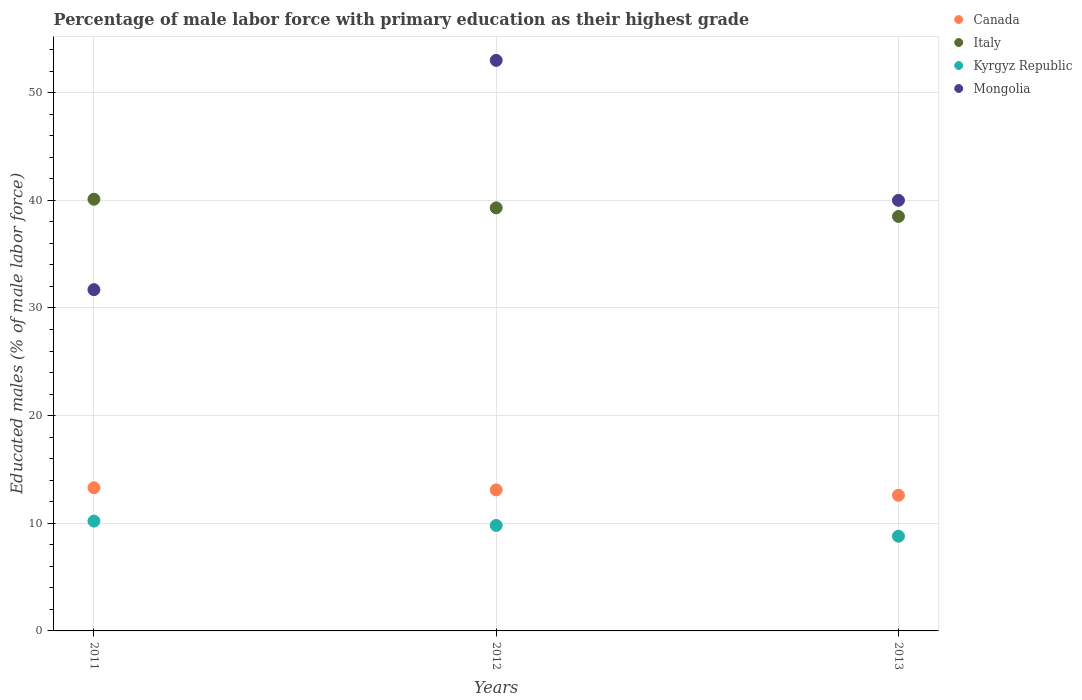How many different coloured dotlines are there?
Your answer should be compact. 4. Across all years, what is the maximum percentage of male labor force with primary education in Italy?
Offer a terse response. 40.1. Across all years, what is the minimum percentage of male labor force with primary education in Canada?
Make the answer very short. 12.6. What is the total percentage of male labor force with primary education in Kyrgyz Republic in the graph?
Offer a terse response. 28.8. What is the difference between the percentage of male labor force with primary education in Italy in 2011 and that in 2012?
Your answer should be very brief. 0.8. What is the difference between the percentage of male labor force with primary education in Kyrgyz Republic in 2011 and the percentage of male labor force with primary education in Italy in 2013?
Keep it short and to the point. -28.3. What is the average percentage of male labor force with primary education in Kyrgyz Republic per year?
Provide a short and direct response. 9.6. In the year 2012, what is the difference between the percentage of male labor force with primary education in Kyrgyz Republic and percentage of male labor force with primary education in Canada?
Ensure brevity in your answer.  -3.3. In how many years, is the percentage of male labor force with primary education in Italy greater than 12 %?
Keep it short and to the point. 3. What is the ratio of the percentage of male labor force with primary education in Italy in 2012 to that in 2013?
Keep it short and to the point. 1.02. What is the difference between the highest and the second highest percentage of male labor force with primary education in Canada?
Provide a short and direct response. 0.2. What is the difference between the highest and the lowest percentage of male labor force with primary education in Kyrgyz Republic?
Your answer should be very brief. 1.4. In how many years, is the percentage of male labor force with primary education in Canada greater than the average percentage of male labor force with primary education in Canada taken over all years?
Your answer should be very brief. 2. Is it the case that in every year, the sum of the percentage of male labor force with primary education in Mongolia and percentage of male labor force with primary education in Kyrgyz Republic  is greater than the sum of percentage of male labor force with primary education in Canada and percentage of male labor force with primary education in Italy?
Make the answer very short. Yes. Is it the case that in every year, the sum of the percentage of male labor force with primary education in Canada and percentage of male labor force with primary education in Mongolia  is greater than the percentage of male labor force with primary education in Kyrgyz Republic?
Provide a succinct answer. Yes. How many dotlines are there?
Provide a short and direct response. 4. What is the difference between two consecutive major ticks on the Y-axis?
Your answer should be compact. 10. Does the graph contain grids?
Offer a very short reply. Yes. Where does the legend appear in the graph?
Provide a succinct answer. Top right. How many legend labels are there?
Offer a very short reply. 4. How are the legend labels stacked?
Provide a succinct answer. Vertical. What is the title of the graph?
Provide a succinct answer. Percentage of male labor force with primary education as their highest grade. Does "Cambodia" appear as one of the legend labels in the graph?
Provide a succinct answer. No. What is the label or title of the X-axis?
Make the answer very short. Years. What is the label or title of the Y-axis?
Give a very brief answer. Educated males (% of male labor force). What is the Educated males (% of male labor force) in Canada in 2011?
Give a very brief answer. 13.3. What is the Educated males (% of male labor force) of Italy in 2011?
Make the answer very short. 40.1. What is the Educated males (% of male labor force) in Kyrgyz Republic in 2011?
Provide a succinct answer. 10.2. What is the Educated males (% of male labor force) of Mongolia in 2011?
Your answer should be very brief. 31.7. What is the Educated males (% of male labor force) in Canada in 2012?
Offer a very short reply. 13.1. What is the Educated males (% of male labor force) in Italy in 2012?
Keep it short and to the point. 39.3. What is the Educated males (% of male labor force) in Kyrgyz Republic in 2012?
Ensure brevity in your answer.  9.8. What is the Educated males (% of male labor force) in Mongolia in 2012?
Your answer should be very brief. 53. What is the Educated males (% of male labor force) of Canada in 2013?
Make the answer very short. 12.6. What is the Educated males (% of male labor force) in Italy in 2013?
Your answer should be very brief. 38.5. What is the Educated males (% of male labor force) in Kyrgyz Republic in 2013?
Your answer should be compact. 8.8. What is the Educated males (% of male labor force) in Mongolia in 2013?
Your response must be concise. 40. Across all years, what is the maximum Educated males (% of male labor force) of Canada?
Your answer should be compact. 13.3. Across all years, what is the maximum Educated males (% of male labor force) in Italy?
Make the answer very short. 40.1. Across all years, what is the maximum Educated males (% of male labor force) of Kyrgyz Republic?
Provide a succinct answer. 10.2. Across all years, what is the maximum Educated males (% of male labor force) of Mongolia?
Provide a short and direct response. 53. Across all years, what is the minimum Educated males (% of male labor force) of Canada?
Ensure brevity in your answer.  12.6. Across all years, what is the minimum Educated males (% of male labor force) in Italy?
Ensure brevity in your answer.  38.5. Across all years, what is the minimum Educated males (% of male labor force) in Kyrgyz Republic?
Provide a short and direct response. 8.8. Across all years, what is the minimum Educated males (% of male labor force) in Mongolia?
Ensure brevity in your answer.  31.7. What is the total Educated males (% of male labor force) of Canada in the graph?
Offer a terse response. 39. What is the total Educated males (% of male labor force) in Italy in the graph?
Offer a very short reply. 117.9. What is the total Educated males (% of male labor force) in Kyrgyz Republic in the graph?
Offer a terse response. 28.8. What is the total Educated males (% of male labor force) in Mongolia in the graph?
Keep it short and to the point. 124.7. What is the difference between the Educated males (% of male labor force) of Canada in 2011 and that in 2012?
Your answer should be very brief. 0.2. What is the difference between the Educated males (% of male labor force) of Mongolia in 2011 and that in 2012?
Offer a very short reply. -21.3. What is the difference between the Educated males (% of male labor force) in Canada in 2011 and that in 2013?
Offer a terse response. 0.7. What is the difference between the Educated males (% of male labor force) of Italy in 2011 and that in 2013?
Provide a short and direct response. 1.6. What is the difference between the Educated males (% of male labor force) in Mongolia in 2012 and that in 2013?
Provide a succinct answer. 13. What is the difference between the Educated males (% of male labor force) of Canada in 2011 and the Educated males (% of male labor force) of Kyrgyz Republic in 2012?
Provide a short and direct response. 3.5. What is the difference between the Educated males (% of male labor force) of Canada in 2011 and the Educated males (% of male labor force) of Mongolia in 2012?
Provide a succinct answer. -39.7. What is the difference between the Educated males (% of male labor force) of Italy in 2011 and the Educated males (% of male labor force) of Kyrgyz Republic in 2012?
Provide a short and direct response. 30.3. What is the difference between the Educated males (% of male labor force) of Italy in 2011 and the Educated males (% of male labor force) of Mongolia in 2012?
Provide a succinct answer. -12.9. What is the difference between the Educated males (% of male labor force) in Kyrgyz Republic in 2011 and the Educated males (% of male labor force) in Mongolia in 2012?
Keep it short and to the point. -42.8. What is the difference between the Educated males (% of male labor force) of Canada in 2011 and the Educated males (% of male labor force) of Italy in 2013?
Your response must be concise. -25.2. What is the difference between the Educated males (% of male labor force) in Canada in 2011 and the Educated males (% of male labor force) in Kyrgyz Republic in 2013?
Your answer should be compact. 4.5. What is the difference between the Educated males (% of male labor force) of Canada in 2011 and the Educated males (% of male labor force) of Mongolia in 2013?
Offer a very short reply. -26.7. What is the difference between the Educated males (% of male labor force) in Italy in 2011 and the Educated males (% of male labor force) in Kyrgyz Republic in 2013?
Keep it short and to the point. 31.3. What is the difference between the Educated males (% of male labor force) in Italy in 2011 and the Educated males (% of male labor force) in Mongolia in 2013?
Provide a succinct answer. 0.1. What is the difference between the Educated males (% of male labor force) in Kyrgyz Republic in 2011 and the Educated males (% of male labor force) in Mongolia in 2013?
Make the answer very short. -29.8. What is the difference between the Educated males (% of male labor force) in Canada in 2012 and the Educated males (% of male labor force) in Italy in 2013?
Provide a short and direct response. -25.4. What is the difference between the Educated males (% of male labor force) of Canada in 2012 and the Educated males (% of male labor force) of Kyrgyz Republic in 2013?
Provide a succinct answer. 4.3. What is the difference between the Educated males (% of male labor force) of Canada in 2012 and the Educated males (% of male labor force) of Mongolia in 2013?
Offer a very short reply. -26.9. What is the difference between the Educated males (% of male labor force) in Italy in 2012 and the Educated males (% of male labor force) in Kyrgyz Republic in 2013?
Your answer should be very brief. 30.5. What is the difference between the Educated males (% of male labor force) of Kyrgyz Republic in 2012 and the Educated males (% of male labor force) of Mongolia in 2013?
Provide a succinct answer. -30.2. What is the average Educated males (% of male labor force) in Canada per year?
Provide a succinct answer. 13. What is the average Educated males (% of male labor force) of Italy per year?
Ensure brevity in your answer.  39.3. What is the average Educated males (% of male labor force) in Kyrgyz Republic per year?
Ensure brevity in your answer.  9.6. What is the average Educated males (% of male labor force) in Mongolia per year?
Your response must be concise. 41.57. In the year 2011, what is the difference between the Educated males (% of male labor force) of Canada and Educated males (% of male labor force) of Italy?
Your answer should be compact. -26.8. In the year 2011, what is the difference between the Educated males (% of male labor force) of Canada and Educated males (% of male labor force) of Kyrgyz Republic?
Offer a terse response. 3.1. In the year 2011, what is the difference between the Educated males (% of male labor force) in Canada and Educated males (% of male labor force) in Mongolia?
Provide a succinct answer. -18.4. In the year 2011, what is the difference between the Educated males (% of male labor force) of Italy and Educated males (% of male labor force) of Kyrgyz Republic?
Keep it short and to the point. 29.9. In the year 2011, what is the difference between the Educated males (% of male labor force) of Kyrgyz Republic and Educated males (% of male labor force) of Mongolia?
Provide a succinct answer. -21.5. In the year 2012, what is the difference between the Educated males (% of male labor force) of Canada and Educated males (% of male labor force) of Italy?
Offer a terse response. -26.2. In the year 2012, what is the difference between the Educated males (% of male labor force) in Canada and Educated males (% of male labor force) in Mongolia?
Your answer should be very brief. -39.9. In the year 2012, what is the difference between the Educated males (% of male labor force) of Italy and Educated males (% of male labor force) of Kyrgyz Republic?
Keep it short and to the point. 29.5. In the year 2012, what is the difference between the Educated males (% of male labor force) in Italy and Educated males (% of male labor force) in Mongolia?
Provide a succinct answer. -13.7. In the year 2012, what is the difference between the Educated males (% of male labor force) in Kyrgyz Republic and Educated males (% of male labor force) in Mongolia?
Keep it short and to the point. -43.2. In the year 2013, what is the difference between the Educated males (% of male labor force) of Canada and Educated males (% of male labor force) of Italy?
Keep it short and to the point. -25.9. In the year 2013, what is the difference between the Educated males (% of male labor force) of Canada and Educated males (% of male labor force) of Mongolia?
Provide a short and direct response. -27.4. In the year 2013, what is the difference between the Educated males (% of male labor force) of Italy and Educated males (% of male labor force) of Kyrgyz Republic?
Offer a terse response. 29.7. In the year 2013, what is the difference between the Educated males (% of male labor force) in Italy and Educated males (% of male labor force) in Mongolia?
Your response must be concise. -1.5. In the year 2013, what is the difference between the Educated males (% of male labor force) of Kyrgyz Republic and Educated males (% of male labor force) of Mongolia?
Offer a very short reply. -31.2. What is the ratio of the Educated males (% of male labor force) of Canada in 2011 to that in 2012?
Your answer should be compact. 1.02. What is the ratio of the Educated males (% of male labor force) in Italy in 2011 to that in 2012?
Provide a short and direct response. 1.02. What is the ratio of the Educated males (% of male labor force) of Kyrgyz Republic in 2011 to that in 2012?
Your response must be concise. 1.04. What is the ratio of the Educated males (% of male labor force) of Mongolia in 2011 to that in 2012?
Your answer should be very brief. 0.6. What is the ratio of the Educated males (% of male labor force) of Canada in 2011 to that in 2013?
Keep it short and to the point. 1.06. What is the ratio of the Educated males (% of male labor force) in Italy in 2011 to that in 2013?
Provide a succinct answer. 1.04. What is the ratio of the Educated males (% of male labor force) of Kyrgyz Republic in 2011 to that in 2013?
Offer a very short reply. 1.16. What is the ratio of the Educated males (% of male labor force) in Mongolia in 2011 to that in 2013?
Your answer should be compact. 0.79. What is the ratio of the Educated males (% of male labor force) of Canada in 2012 to that in 2013?
Your answer should be compact. 1.04. What is the ratio of the Educated males (% of male labor force) in Italy in 2012 to that in 2013?
Offer a terse response. 1.02. What is the ratio of the Educated males (% of male labor force) in Kyrgyz Republic in 2012 to that in 2013?
Give a very brief answer. 1.11. What is the ratio of the Educated males (% of male labor force) of Mongolia in 2012 to that in 2013?
Offer a very short reply. 1.32. What is the difference between the highest and the second highest Educated males (% of male labor force) in Kyrgyz Republic?
Ensure brevity in your answer.  0.4. What is the difference between the highest and the lowest Educated males (% of male labor force) of Canada?
Keep it short and to the point. 0.7. What is the difference between the highest and the lowest Educated males (% of male labor force) of Kyrgyz Republic?
Keep it short and to the point. 1.4. What is the difference between the highest and the lowest Educated males (% of male labor force) in Mongolia?
Offer a very short reply. 21.3. 